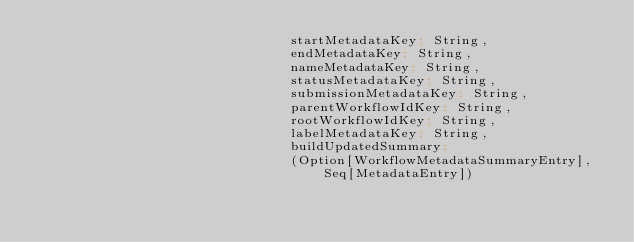Convert code to text. <code><loc_0><loc_0><loc_500><loc_500><_Scala_>                                startMetadataKey: String,
                                endMetadataKey: String,
                                nameMetadataKey: String,
                                statusMetadataKey: String,
                                submissionMetadataKey: String,
                                parentWorkflowIdKey: String,
                                rootWorkflowIdKey: String,
                                labelMetadataKey: String,
                                buildUpdatedSummary:
                                (Option[WorkflowMetadataSummaryEntry], Seq[MetadataEntry])</code> 